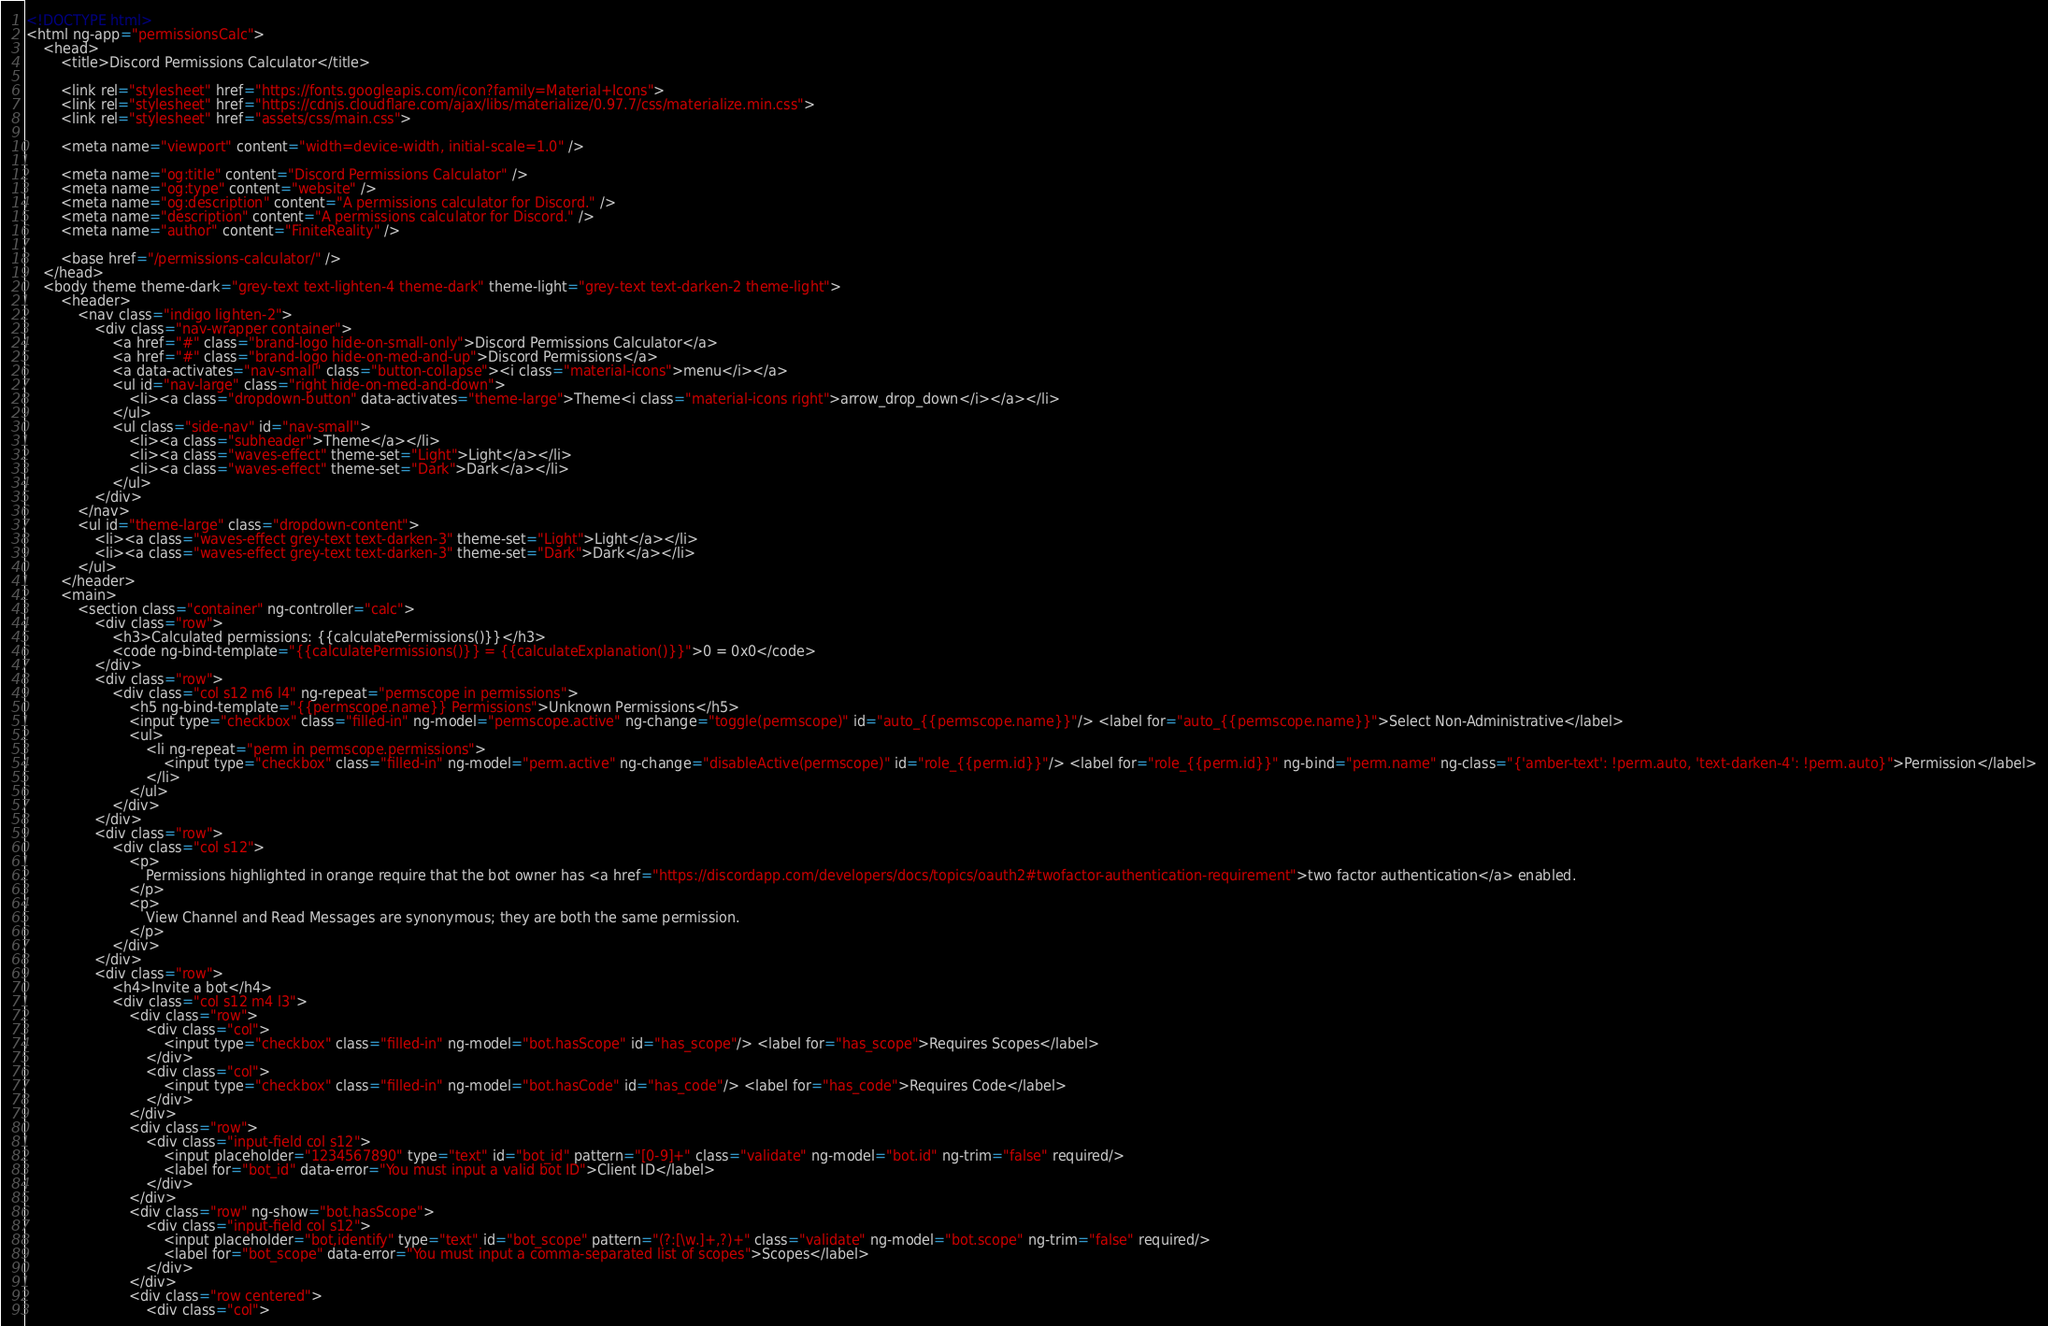Convert code to text. <code><loc_0><loc_0><loc_500><loc_500><_HTML_><!DOCTYPE html>
<html ng-app="permissionsCalc">
    <head>
        <title>Discord Permissions Calculator</title>

        <link rel="stylesheet" href="https://fonts.googleapis.com/icon?family=Material+Icons">
        <link rel="stylesheet" href="https://cdnjs.cloudflare.com/ajax/libs/materialize/0.97.7/css/materialize.min.css">
        <link rel="stylesheet" href="assets/css/main.css">

        <meta name="viewport" content="width=device-width, initial-scale=1.0" />

        <meta name="og:title" content="Discord Permissions Calculator" />
        <meta name="og:type" content="website" />
        <meta name="og:description" content="A permissions calculator for Discord." />
        <meta name="description" content="A permissions calculator for Discord." />
        <meta name="author" content="FiniteReality" />

        <base href="/permissions-calculator/" />
    </head>
    <body theme theme-dark="grey-text text-lighten-4 theme-dark" theme-light="grey-text text-darken-2 theme-light">
        <header>
            <nav class="indigo lighten-2">
                <div class="nav-wrapper container">
                    <a href="#" class="brand-logo hide-on-small-only">Discord Permissions Calculator</a>
                    <a href="#" class="brand-logo hide-on-med-and-up">Discord Permissions</a>
                    <a data-activates="nav-small" class="button-collapse"><i class="material-icons">menu</i></a>
                    <ul id="nav-large" class="right hide-on-med-and-down">
                        <li><a class="dropdown-button" data-activates="theme-large">Theme<i class="material-icons right">arrow_drop_down</i></a></li>
                    </ul>
                    <ul class="side-nav" id="nav-small">
                        <li><a class="subheader">Theme</a></li>
                        <li><a class="waves-effect" theme-set="Light">Light</a></li>
                        <li><a class="waves-effect" theme-set="Dark">Dark</a></li>
                    </ul>
                </div>
            </nav>
            <ul id="theme-large" class="dropdown-content">
                <li><a class="waves-effect grey-text text-darken-3" theme-set="Light">Light</a></li>
                <li><a class="waves-effect grey-text text-darken-3" theme-set="Dark">Dark</a></li>
            </ul>
        </header>
        <main>
            <section class="container" ng-controller="calc">
                <div class="row">
                    <h3>Calculated permissions: {{calculatePermissions()}}</h3>
                    <code ng-bind-template="{{calculatePermissions()}} = {{calculateExplanation()}}">0 = 0x0</code>
                </div>
                <div class="row">
                    <div class="col s12 m6 l4" ng-repeat="permscope in permissions">
                        <h5 ng-bind-template="{{permscope.name}} Permissions">Unknown Permissions</h5>
                        <input type="checkbox" class="filled-in" ng-model="permscope.active" ng-change="toggle(permscope)" id="auto_{{permscope.name}}"/> <label for="auto_{{permscope.name}}">Select Non-Administrative</label>
                        <ul>
                            <li ng-repeat="perm in permscope.permissions">
                                <input type="checkbox" class="filled-in" ng-model="perm.active" ng-change="disableActive(permscope)" id="role_{{perm.id}}"/> <label for="role_{{perm.id}}" ng-bind="perm.name" ng-class="{'amber-text': !perm.auto, 'text-darken-4': !perm.auto}">Permission</label>
                            </li>
                        </ul>
                    </div>
                </div>
                <div class="row">
                    <div class="col s12">
                        <p>
                            Permissions highlighted in orange require that the bot owner has <a href="https://discordapp.com/developers/docs/topics/oauth2#twofactor-authentication-requirement">two factor authentication</a> enabled.
                        </p>
                        <p>
                            View Channel and Read Messages are synonymous; they are both the same permission.
                        </p>
                    </div>
                </div>
                <div class="row">
                    <h4>Invite a bot</h4>
                    <div class="col s12 m4 l3">
                        <div class="row">
                            <div class="col">
                                <input type="checkbox" class="filled-in" ng-model="bot.hasScope" id="has_scope"/> <label for="has_scope">Requires Scopes</label>
                            </div>
                            <div class="col">
                                <input type="checkbox" class="filled-in" ng-model="bot.hasCode" id="has_code"/> <label for="has_code">Requires Code</label>
                            </div>
                        </div>
                        <div class="row">
                            <div class="input-field col s12">
                                <input placeholder="1234567890" type="text" id="bot_id" pattern="[0-9]+" class="validate" ng-model="bot.id" ng-trim="false" required/>
                                <label for="bot_id" data-error="You must input a valid bot ID">Client ID</label>
                            </div>
                        </div>
                        <div class="row" ng-show="bot.hasScope">
                            <div class="input-field col s12">
                                <input placeholder="bot,identify" type="text" id="bot_scope" pattern="(?:[\w.]+,?)+" class="validate" ng-model="bot.scope" ng-trim="false" required/>
                                <label for="bot_scope" data-error="You must input a comma-separated list of scopes">Scopes</label>
                            </div>
                        </div>
                        <div class="row centered">
                            <div class="col"></code> 